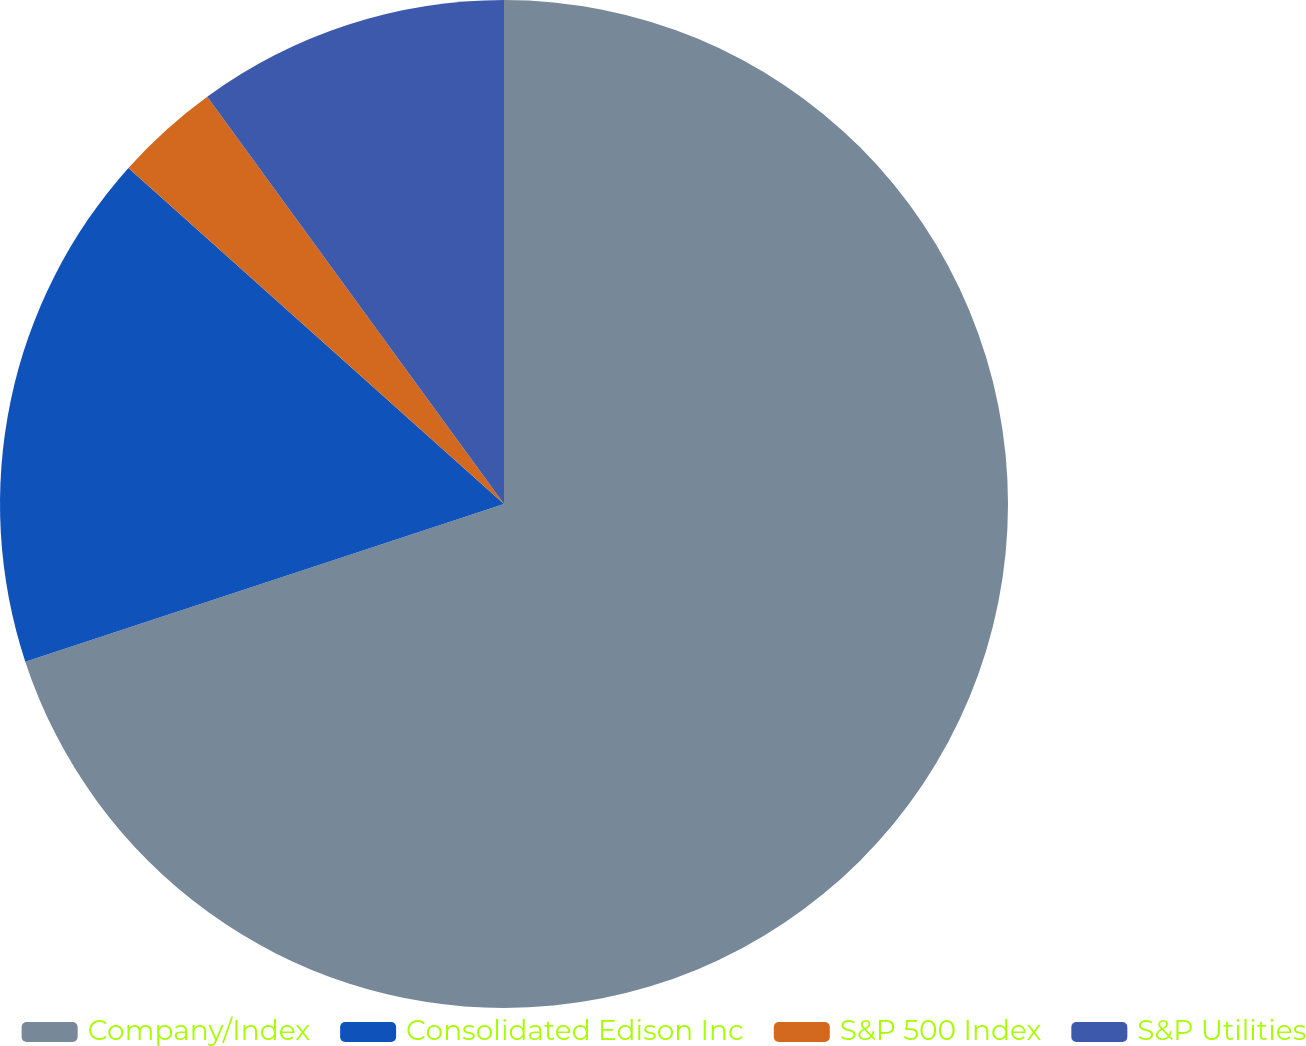Convert chart. <chart><loc_0><loc_0><loc_500><loc_500><pie_chart><fcel>Company/Index<fcel>Consolidated Edison Inc<fcel>S&P 500 Index<fcel>S&P Utilities<nl><fcel>69.93%<fcel>16.68%<fcel>3.36%<fcel>10.02%<nl></chart> 